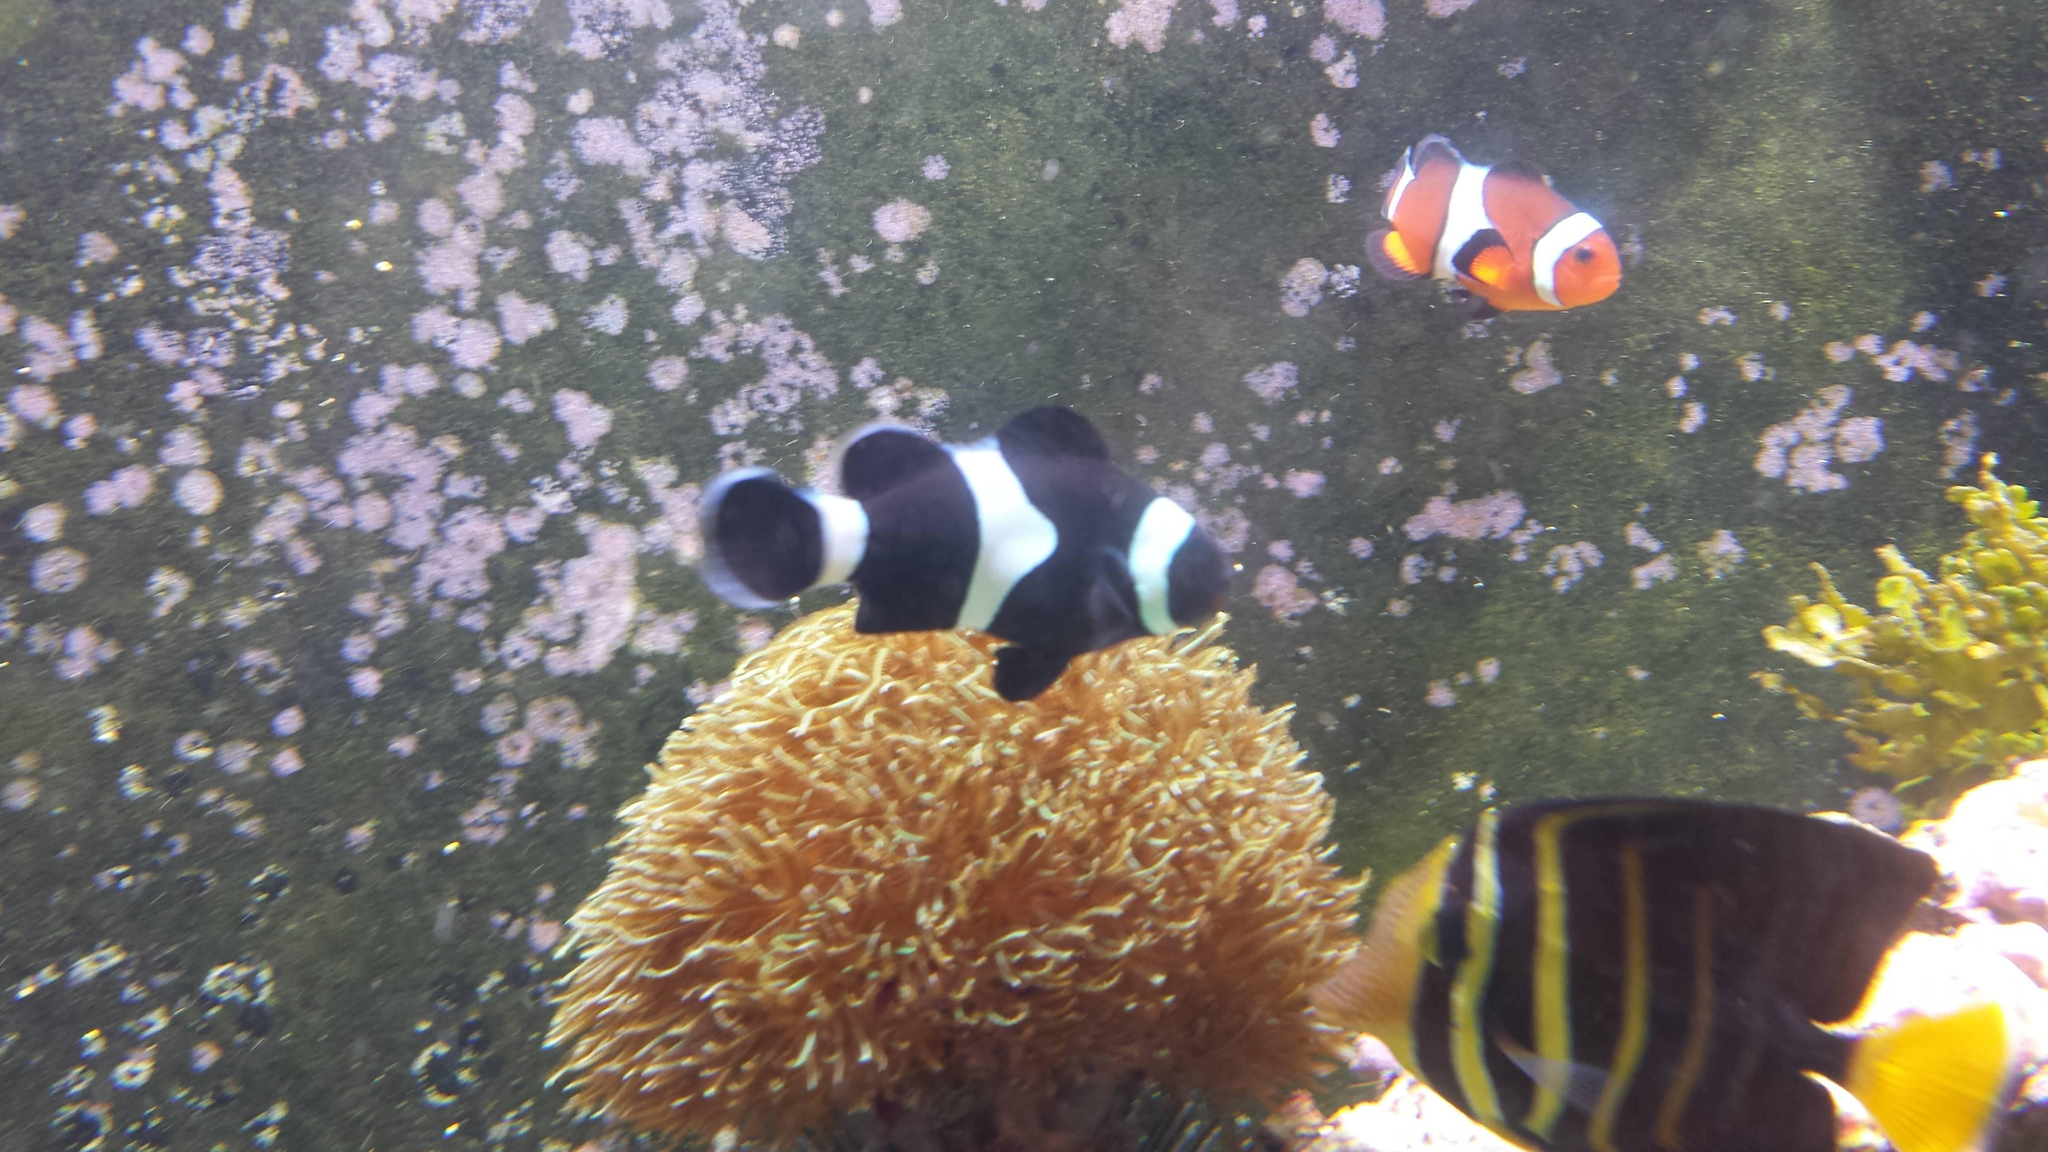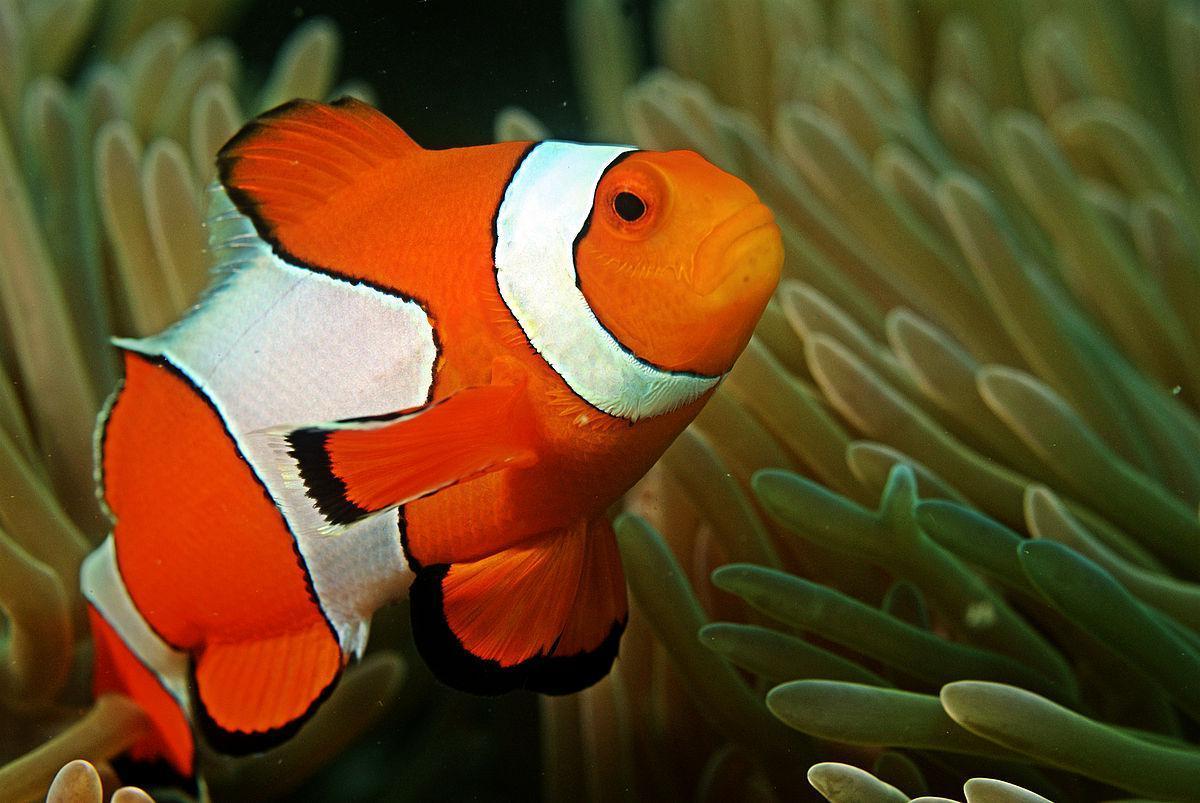The first image is the image on the left, the second image is the image on the right. For the images shown, is this caption "There is exactly one fish in the image on the right." true? Answer yes or no. Yes. The first image is the image on the left, the second image is the image on the right. For the images displayed, is the sentence "The right image shows more than one clown fish swimming among tube shapes." factually correct? Answer yes or no. No. 